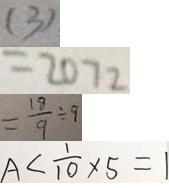Convert formula to latex. <formula><loc_0><loc_0><loc_500><loc_500>( 3 ) 
 = 2 0 7 2 
 = \frac { 1 8 } { 9 } \div 9 
 A < \frac { 1 } { 1 0 } \times 5 = 1</formula> 